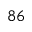<formula> <loc_0><loc_0><loc_500><loc_500>^ { 8 6 }</formula> 